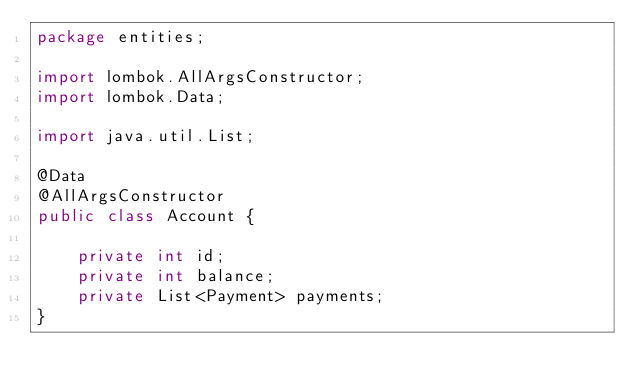<code> <loc_0><loc_0><loc_500><loc_500><_Java_>package entities;

import lombok.AllArgsConstructor;
import lombok.Data;

import java.util.List;

@Data
@AllArgsConstructor
public class Account {

    private int id;
    private int balance;
    private List<Payment> payments;
}
</code> 